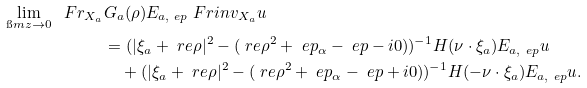Convert formula to latex. <formula><loc_0><loc_0><loc_500><loc_500>\lim _ { \i m z \to 0 } \ F r _ { X _ { a } } & G _ { a } ( \rho ) E _ { a , \ e p } \ F r i n v _ { X _ { a } } u \\ & = ( | \xi _ { a } + \ r e \rho | ^ { 2 } - ( \ r e \rho ^ { 2 } + \ e p _ { \alpha } - \ e p - i 0 ) ) ^ { - 1 } H ( \nu \cdot \xi _ { a } ) E _ { a , \ e p } u \\ & \quad + ( | \xi _ { a } + \ r e \rho | ^ { 2 } - ( \ r e \rho ^ { 2 } + \ e p _ { \alpha } - \ e p + i 0 ) ) ^ { - 1 } H ( - \nu \cdot \xi _ { a } ) E _ { a , \ e p } u .</formula> 